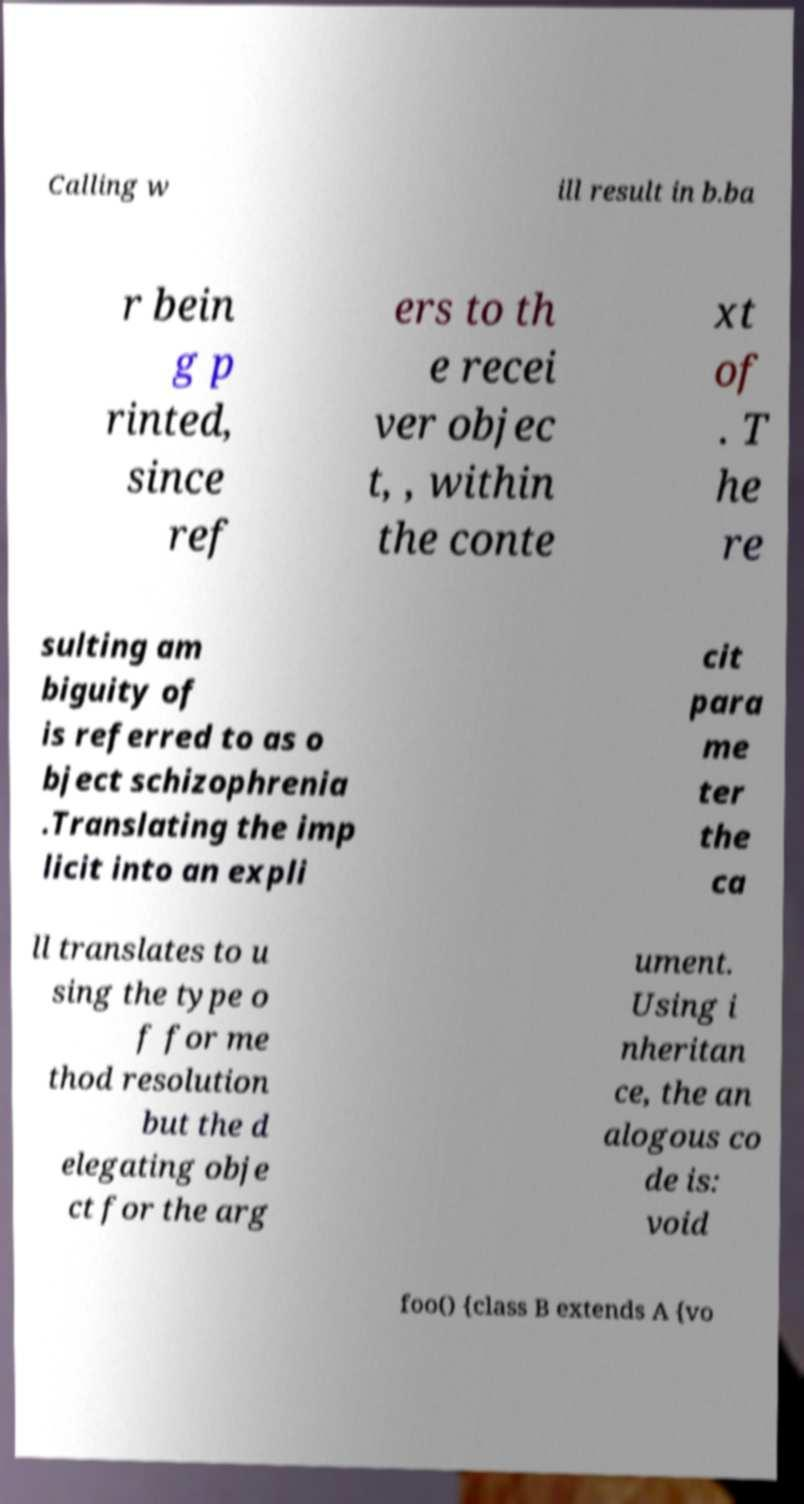Could you assist in decoding the text presented in this image and type it out clearly? Calling w ill result in b.ba r bein g p rinted, since ref ers to th e recei ver objec t, , within the conte xt of . T he re sulting am biguity of is referred to as o bject schizophrenia .Translating the imp licit into an expli cit para me ter the ca ll translates to u sing the type o f for me thod resolution but the d elegating obje ct for the arg ument. Using i nheritan ce, the an alogous co de is: void foo() {class B extends A {vo 